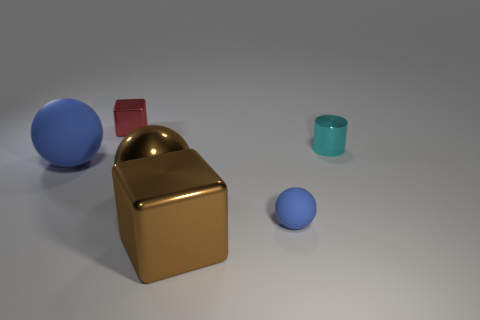How many brown metallic balls are the same size as the brown block?
Make the answer very short. 1. There is a small rubber thing that is the same color as the big rubber object; what is its shape?
Give a very brief answer. Sphere. What shape is the tiny metallic thing on the left side of the metallic cylinder that is in front of the metallic block that is behind the cylinder?
Offer a terse response. Cube. There is a rubber object in front of the large blue ball; what is its color?
Make the answer very short. Blue. What number of things are blue matte things on the left side of the red cube or matte objects behind the brown metallic sphere?
Give a very brief answer. 1. How many other things are the same shape as the small red shiny object?
Ensure brevity in your answer.  1. There is another matte thing that is the same size as the cyan thing; what is its color?
Make the answer very short. Blue. What color is the cube right of the shiny cube to the left of the big ball that is right of the large blue matte object?
Provide a short and direct response. Brown. Does the cyan cylinder have the same size as the cube that is in front of the cyan metal cylinder?
Provide a succinct answer. No. How many things are rubber things or cylinders?
Offer a terse response. 3. 